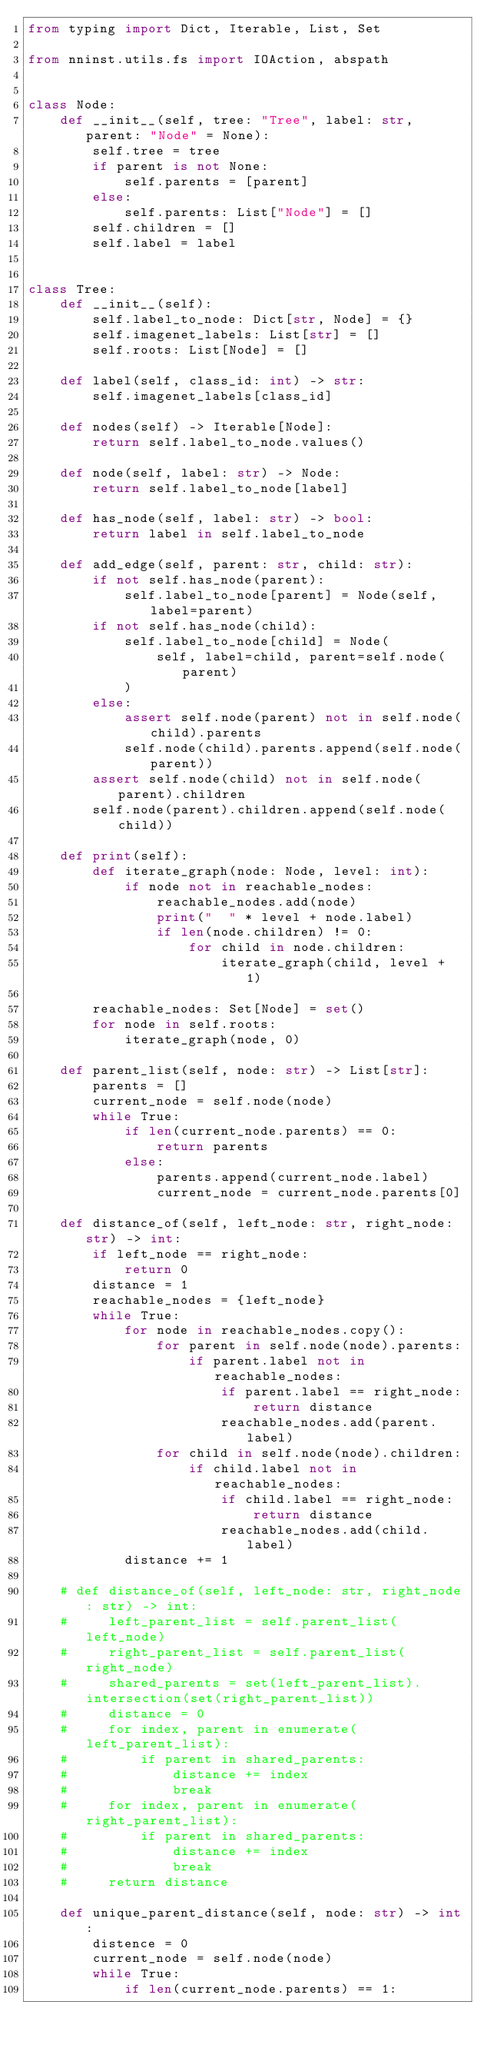Convert code to text. <code><loc_0><loc_0><loc_500><loc_500><_Python_>from typing import Dict, Iterable, List, Set

from nninst.utils.fs import IOAction, abspath


class Node:
    def __init__(self, tree: "Tree", label: str, parent: "Node" = None):
        self.tree = tree
        if parent is not None:
            self.parents = [parent]
        else:
            self.parents: List["Node"] = []
        self.children = []
        self.label = label


class Tree:
    def __init__(self):
        self.label_to_node: Dict[str, Node] = {}
        self.imagenet_labels: List[str] = []
        self.roots: List[Node] = []

    def label(self, class_id: int) -> str:
        self.imagenet_labels[class_id]

    def nodes(self) -> Iterable[Node]:
        return self.label_to_node.values()

    def node(self, label: str) -> Node:
        return self.label_to_node[label]

    def has_node(self, label: str) -> bool:
        return label in self.label_to_node

    def add_edge(self, parent: str, child: str):
        if not self.has_node(parent):
            self.label_to_node[parent] = Node(self, label=parent)
        if not self.has_node(child):
            self.label_to_node[child] = Node(
                self, label=child, parent=self.node(parent)
            )
        else:
            assert self.node(parent) not in self.node(child).parents
            self.node(child).parents.append(self.node(parent))
        assert self.node(child) not in self.node(parent).children
        self.node(parent).children.append(self.node(child))

    def print(self):
        def iterate_graph(node: Node, level: int):
            if node not in reachable_nodes:
                reachable_nodes.add(node)
                print("  " * level + node.label)
                if len(node.children) != 0:
                    for child in node.children:
                        iterate_graph(child, level + 1)

        reachable_nodes: Set[Node] = set()
        for node in self.roots:
            iterate_graph(node, 0)

    def parent_list(self, node: str) -> List[str]:
        parents = []
        current_node = self.node(node)
        while True:
            if len(current_node.parents) == 0:
                return parents
            else:
                parents.append(current_node.label)
                current_node = current_node.parents[0]

    def distance_of(self, left_node: str, right_node: str) -> int:
        if left_node == right_node:
            return 0
        distance = 1
        reachable_nodes = {left_node}
        while True:
            for node in reachable_nodes.copy():
                for parent in self.node(node).parents:
                    if parent.label not in reachable_nodes:
                        if parent.label == right_node:
                            return distance
                        reachable_nodes.add(parent.label)
                for child in self.node(node).children:
                    if child.label not in reachable_nodes:
                        if child.label == right_node:
                            return distance
                        reachable_nodes.add(child.label)
            distance += 1

    # def distance_of(self, left_node: str, right_node: str) -> int:
    #     left_parent_list = self.parent_list(left_node)
    #     right_parent_list = self.parent_list(right_node)
    #     shared_parents = set(left_parent_list).intersection(set(right_parent_list))
    #     distance = 0
    #     for index, parent in enumerate(left_parent_list):
    #         if parent in shared_parents:
    #             distance += index
    #             break
    #     for index, parent in enumerate(right_parent_list):
    #         if parent in shared_parents:
    #             distance += index
    #             break
    #     return distance

    def unique_parent_distance(self, node: str) -> int:
        distence = 0
        current_node = self.node(node)
        while True:
            if len(current_node.parents) == 1:</code> 